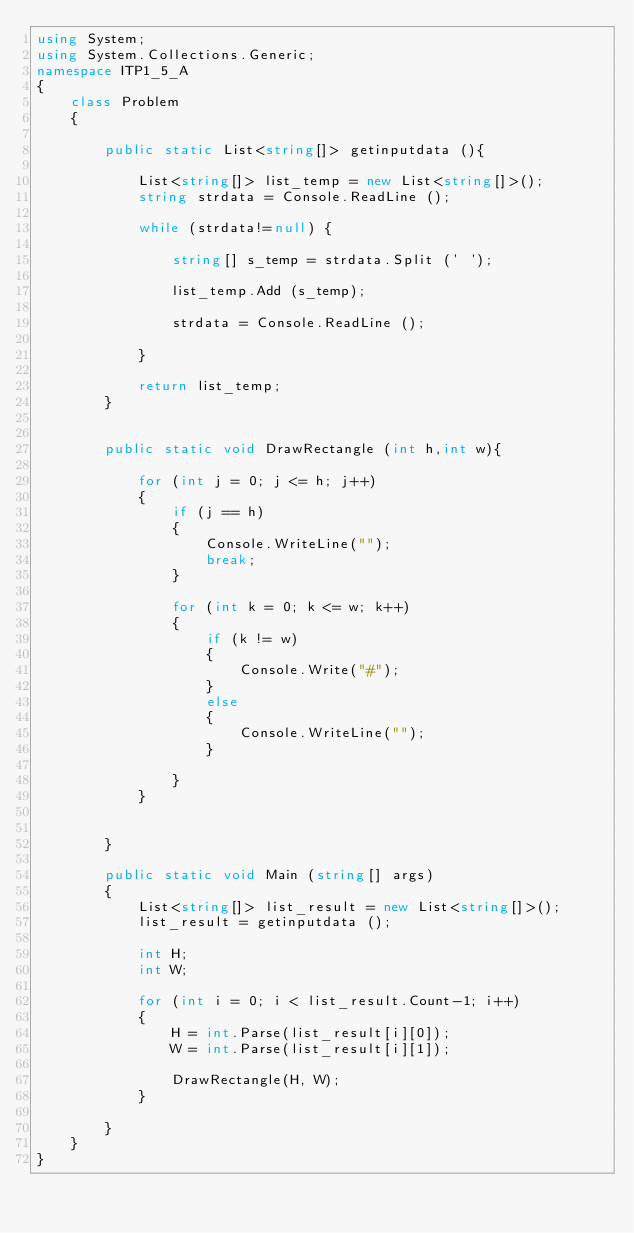Convert code to text. <code><loc_0><loc_0><loc_500><loc_500><_C#_>using System;
using System.Collections.Generic;
namespace ITP1_5_A
{
    class Problem
    {

        public static List<string[]> getinputdata (){

            List<string[]> list_temp = new List<string[]>();
            string strdata = Console.ReadLine ();

            while (strdata!=null) {

                string[] s_temp = strdata.Split (' ');

                list_temp.Add (s_temp);

                strdata = Console.ReadLine ();

            }

            return list_temp;
        }


        public static void DrawRectangle (int h,int w){

            for (int j = 0; j <= h; j++)
            {
                if (j == h)
                {
                    Console.WriteLine("");
                    break;
                }

                for (int k = 0; k <= w; k++)
                {
                    if (k != w)
                    {
                        Console.Write("#");
                    }
                    else
                    {
                        Console.WriteLine("");
                    }

                }
            }


        }

        public static void Main (string[] args)
        {
            List<string[]> list_result = new List<string[]>();
            list_result = getinputdata ();

            int H;
            int W;

            for (int i = 0; i < list_result.Count-1; i++)
            {
                H = int.Parse(list_result[i][0]);
                W = int.Parse(list_result[i][1]);

                DrawRectangle(H, W);
            }

        }
    }
}</code> 